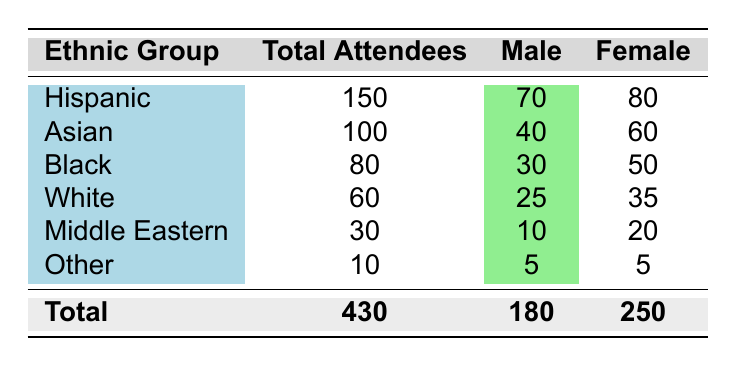What is the total number of attendees across all ethnic groups? To find the total number of attendees, we add the Total Attendees for each ethnic group: 150 (Hispanic) + 100 (Asian) + 80 (Black) + 60 (White) + 30 (Middle Eastern) + 10 (Other) = 430
Answer: 430 Which ethnic group has the highest number of female attendees? Looking at the Female column, the values are: 80 (Hispanic), 60 (Asian), 50 (Black), 35 (White), 20 (Middle Eastern), and 5 (Other). The highest value is 80 from the Hispanic group
Answer: Hispanic Is it true that there are more male attendees than female attendees in the Black ethnic group? In the Black ethnic group, the number of male attendees is 30, and female attendees are 50. Since 30 is less than 50, the statement is false
Answer: No What is the difference in the number of female attendees between the Hispanic and Asian ethnic groups? The number of female attendees in the Hispanic group is 80, and in the Asian group, it is 60. The difference is 80 - 60 = 20
Answer: 20 What percentage of the total attendees are from the White ethnic group? The total number of attendees is 430 and the Total Attendees for the White group is 60. The percentage is calculated as (60/430) * 100 ≈ 13.95%. Rounding gives approximately 14%
Answer: 14% How many total male attendees are there among the Asian and Middle Eastern ethnic groups combined? The number of male attendees in the Asian group is 40, and in the Middle Eastern group, it is 10. Adding these gives: 40 + 10 = 50
Answer: 50 Is the number of attendees in the Other ethnic group greater than the number of attendees in the White ethnic group? The Total Attendees for the Other group is 10 and for the White group is 60. Since 10 is less than 60, the statement is false
Answer: No What is the average number of male attendees across all ethnic groups? To find the average, we need the total number of male attendees: 70 (Hispanic) + 40 (Asian) + 30 (Black) + 25 (White) + 10 (Middle Eastern) + 5 (Other) = 180. There are 6 ethnic groups, so the average is 180 / 6 = 30
Answer: 30 